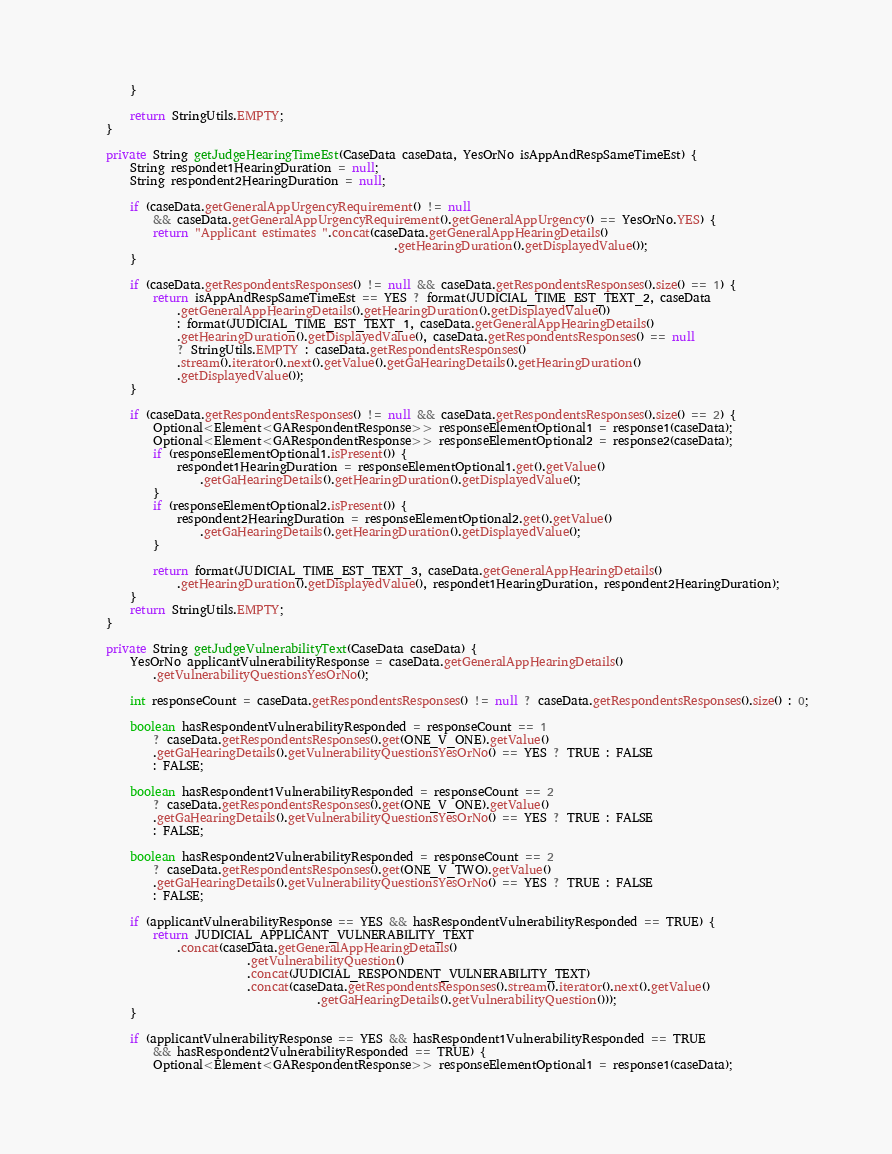Convert code to text. <code><loc_0><loc_0><loc_500><loc_500><_Java_>        }

        return StringUtils.EMPTY;
    }

    private String getJudgeHearingTimeEst(CaseData caseData, YesOrNo isAppAndRespSameTimeEst) {
        String respondet1HearingDuration = null;
        String respondent2HearingDuration = null;

        if (caseData.getGeneralAppUrgencyRequirement() != null
            && caseData.getGeneralAppUrgencyRequirement().getGeneralAppUrgency() == YesOrNo.YES) {
            return "Applicant estimates ".concat(caseData.getGeneralAppHearingDetails()
                                                     .getHearingDuration().getDisplayedValue());
        }

        if (caseData.getRespondentsResponses() != null && caseData.getRespondentsResponses().size() == 1) {
            return isAppAndRespSameTimeEst == YES ? format(JUDICIAL_TIME_EST_TEXT_2, caseData
                .getGeneralAppHearingDetails().getHearingDuration().getDisplayedValue())
                : format(JUDICIAL_TIME_EST_TEXT_1, caseData.getGeneralAppHearingDetails()
                .getHearingDuration().getDisplayedValue(), caseData.getRespondentsResponses() == null
                ? StringUtils.EMPTY : caseData.getRespondentsResponses()
                .stream().iterator().next().getValue().getGaHearingDetails().getHearingDuration()
                .getDisplayedValue());
        }

        if (caseData.getRespondentsResponses() != null && caseData.getRespondentsResponses().size() == 2) {
            Optional<Element<GARespondentResponse>> responseElementOptional1 = response1(caseData);
            Optional<Element<GARespondentResponse>> responseElementOptional2 = response2(caseData);
            if (responseElementOptional1.isPresent()) {
                respondet1HearingDuration = responseElementOptional1.get().getValue()
                    .getGaHearingDetails().getHearingDuration().getDisplayedValue();
            }
            if (responseElementOptional2.isPresent()) {
                respondent2HearingDuration = responseElementOptional2.get().getValue()
                    .getGaHearingDetails().getHearingDuration().getDisplayedValue();
            }

            return format(JUDICIAL_TIME_EST_TEXT_3, caseData.getGeneralAppHearingDetails()
                .getHearingDuration().getDisplayedValue(), respondet1HearingDuration, respondent2HearingDuration);
        }
        return StringUtils.EMPTY;
    }

    private String getJudgeVulnerabilityText(CaseData caseData) {
        YesOrNo applicantVulnerabilityResponse = caseData.getGeneralAppHearingDetails()
            .getVulnerabilityQuestionsYesOrNo();

        int responseCount = caseData.getRespondentsResponses() != null ? caseData.getRespondentsResponses().size() : 0;

        boolean hasRespondentVulnerabilityResponded = responseCount == 1
            ? caseData.getRespondentsResponses().get(ONE_V_ONE).getValue()
            .getGaHearingDetails().getVulnerabilityQuestionsYesOrNo() == YES ? TRUE : FALSE
            : FALSE;

        boolean hasRespondent1VulnerabilityResponded = responseCount == 2
            ? caseData.getRespondentsResponses().get(ONE_V_ONE).getValue()
            .getGaHearingDetails().getVulnerabilityQuestionsYesOrNo() == YES ? TRUE : FALSE
            : FALSE;

        boolean hasRespondent2VulnerabilityResponded = responseCount == 2
            ? caseData.getRespondentsResponses().get(ONE_V_TWO).getValue()
            .getGaHearingDetails().getVulnerabilityQuestionsYesOrNo() == YES ? TRUE : FALSE
            : FALSE;

        if (applicantVulnerabilityResponse == YES && hasRespondentVulnerabilityResponded == TRUE) {
            return JUDICIAL_APPLICANT_VULNERABILITY_TEXT
                .concat(caseData.getGeneralAppHearingDetails()
                            .getVulnerabilityQuestion()
                            .concat(JUDICIAL_RESPONDENT_VULNERABILITY_TEXT)
                            .concat(caseData.getRespondentsResponses().stream().iterator().next().getValue()
                                        .getGaHearingDetails().getVulnerabilityQuestion()));
        }

        if (applicantVulnerabilityResponse == YES && hasRespondent1VulnerabilityResponded == TRUE
            && hasRespondent2VulnerabilityResponded == TRUE) {
            Optional<Element<GARespondentResponse>> responseElementOptional1 = response1(caseData);</code> 